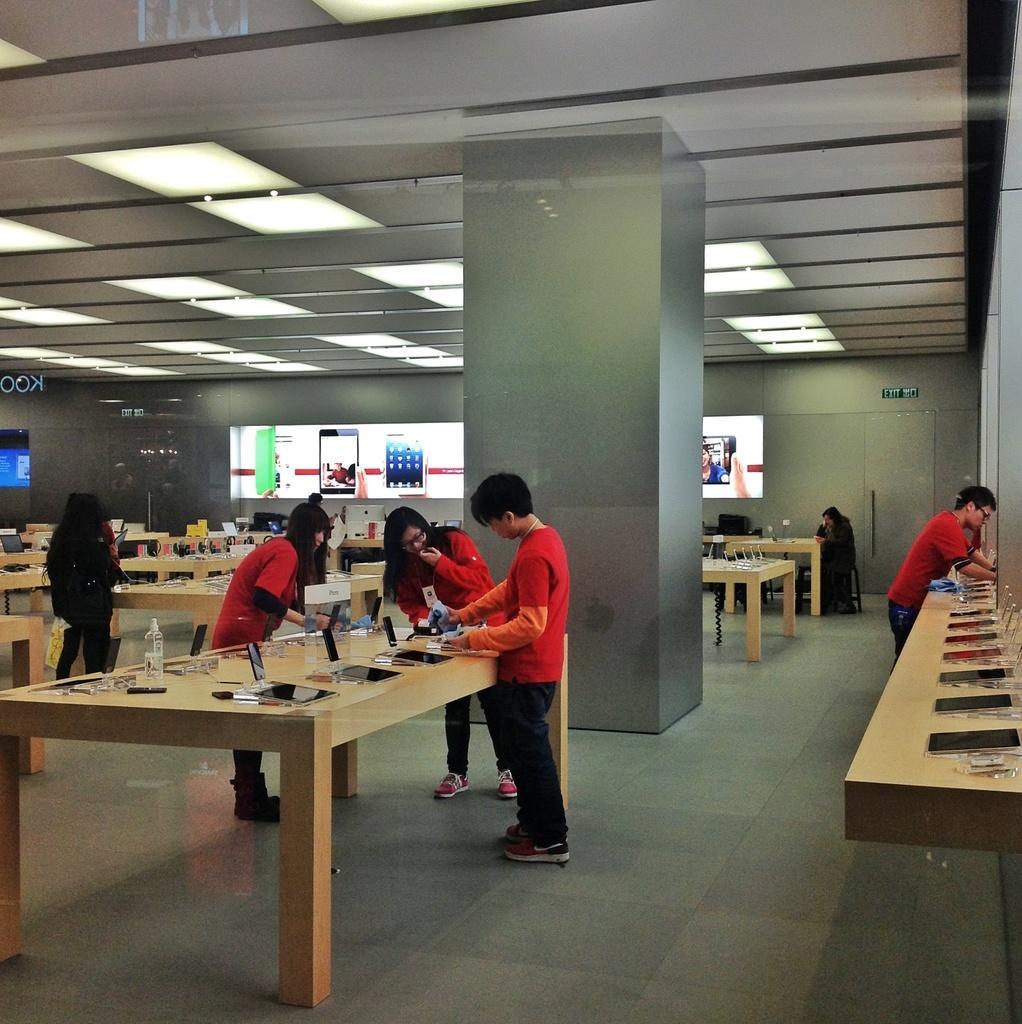Describe this image in one or two sentences. This is a picture of a showroom,in which we can see here a different types of mobiles placed on the table,here we can see different persons wearing red shirts,in this we can notice the screen with mobiles which is on the wall,we can also see lights on the roofs. 